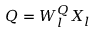<formula> <loc_0><loc_0><loc_500><loc_500>Q = W _ { l } ^ { Q } X _ { l }</formula> 